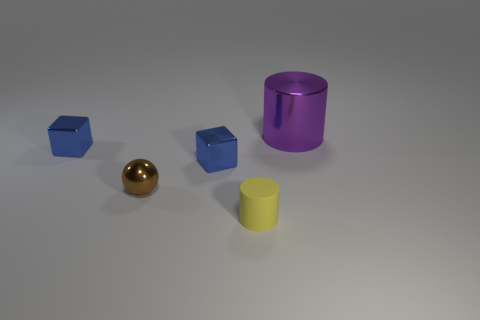Add 3 big gray spheres. How many objects exist? 8 Subtract all blocks. How many objects are left? 3 Subtract 0 purple balls. How many objects are left? 5 Subtract all blue cubes. Subtract all cubes. How many objects are left? 1 Add 4 yellow rubber cylinders. How many yellow rubber cylinders are left? 5 Add 4 big yellow balls. How many big yellow balls exist? 4 